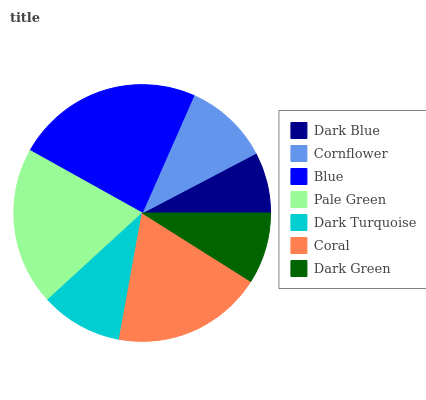Is Dark Blue the minimum?
Answer yes or no. Yes. Is Blue the maximum?
Answer yes or no. Yes. Is Cornflower the minimum?
Answer yes or no. No. Is Cornflower the maximum?
Answer yes or no. No. Is Cornflower greater than Dark Blue?
Answer yes or no. Yes. Is Dark Blue less than Cornflower?
Answer yes or no. Yes. Is Dark Blue greater than Cornflower?
Answer yes or no. No. Is Cornflower less than Dark Blue?
Answer yes or no. No. Is Cornflower the high median?
Answer yes or no. Yes. Is Cornflower the low median?
Answer yes or no. Yes. Is Dark Green the high median?
Answer yes or no. No. Is Pale Green the low median?
Answer yes or no. No. 